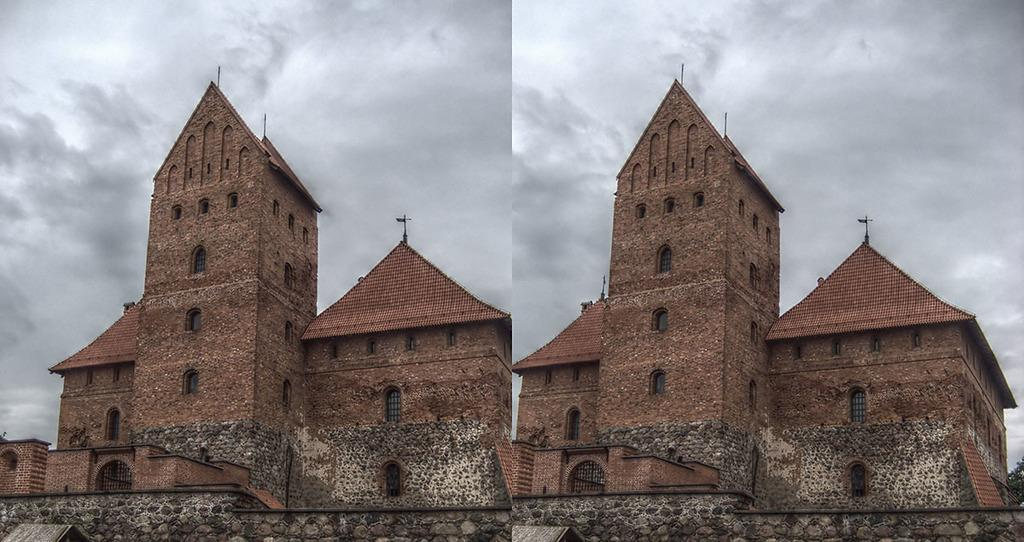What is the composition of the image? The image is a collage containing two images of the same view. What can be seen in the images? There is a building in red color in the images. What is visible at the top of the images? The sky is visible at the top of the images. How would you describe the sky in the images? The sky appears to be cloudy. Can you see a rock being kicked in the images? No, there is no rock or any kicking action present in the images. Is there an oven visible in the images? No, there is no oven present in the images. 